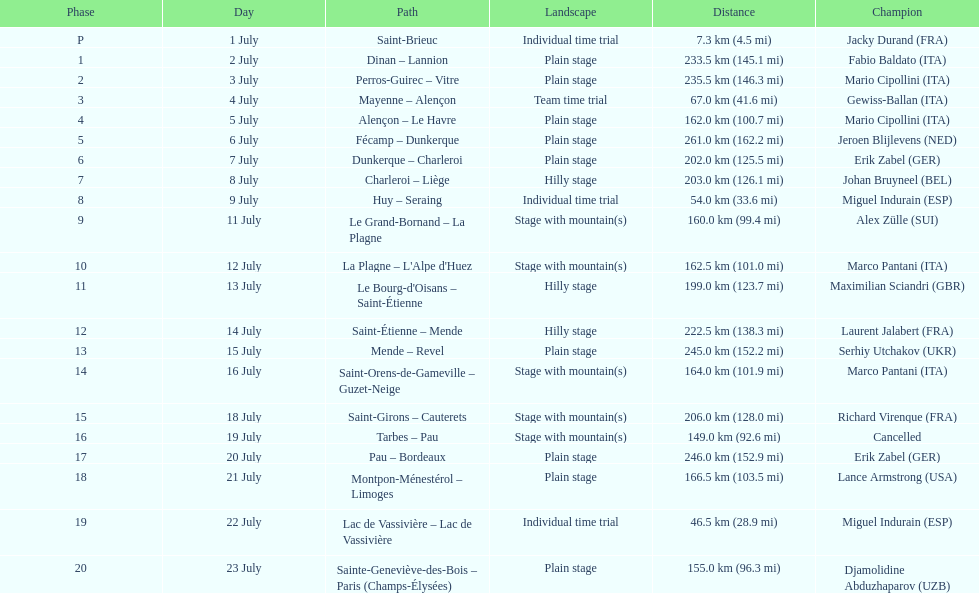How many routes have below 100 km total? 4. 